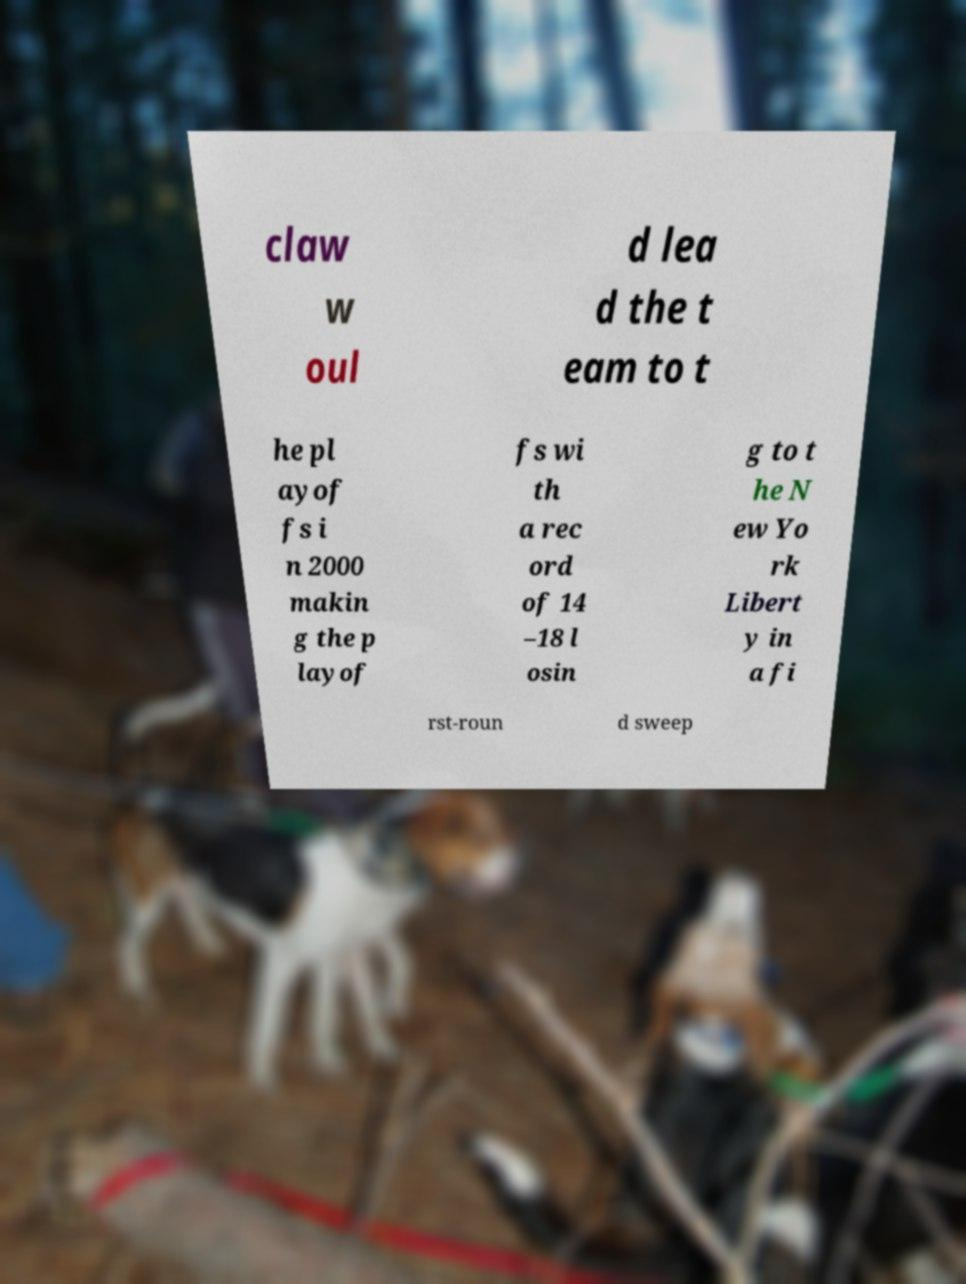Please identify and transcribe the text found in this image. claw w oul d lea d the t eam to t he pl ayof fs i n 2000 makin g the p layof fs wi th a rec ord of 14 –18 l osin g to t he N ew Yo rk Libert y in a fi rst-roun d sweep 